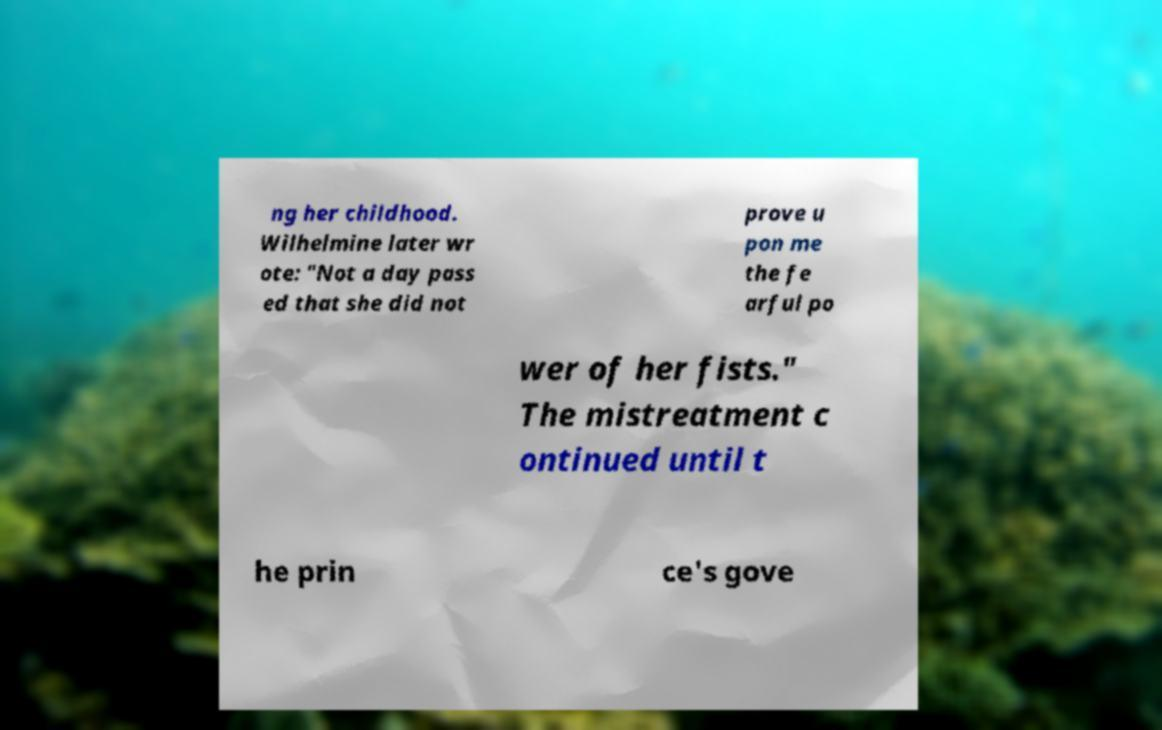There's text embedded in this image that I need extracted. Can you transcribe it verbatim? ng her childhood. Wilhelmine later wr ote: "Not a day pass ed that she did not prove u pon me the fe arful po wer of her fists." The mistreatment c ontinued until t he prin ce's gove 